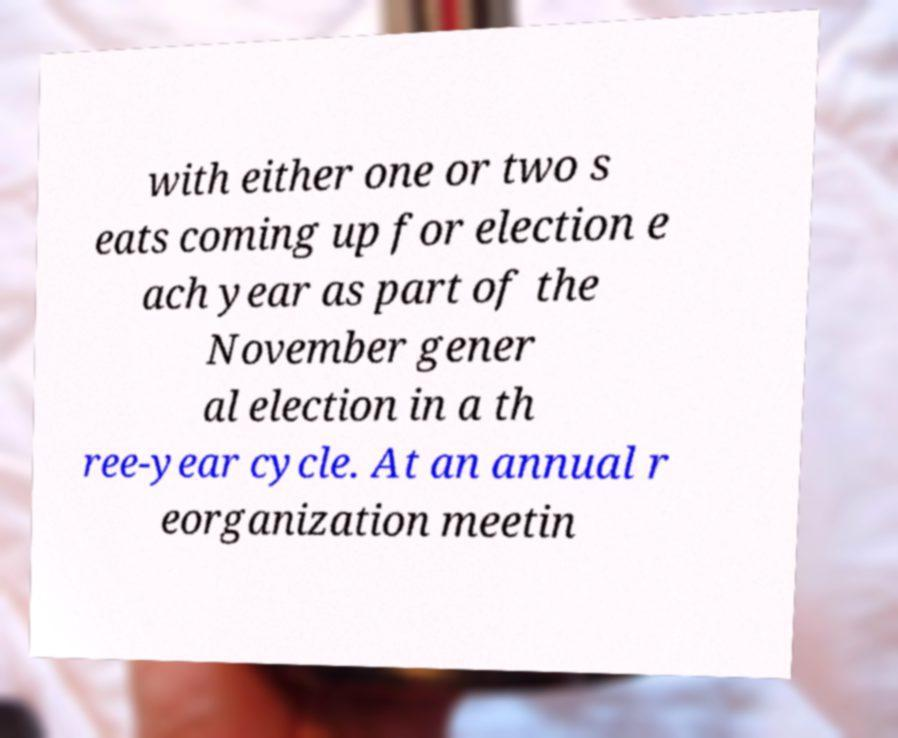Could you assist in decoding the text presented in this image and type it out clearly? with either one or two s eats coming up for election e ach year as part of the November gener al election in a th ree-year cycle. At an annual r eorganization meetin 